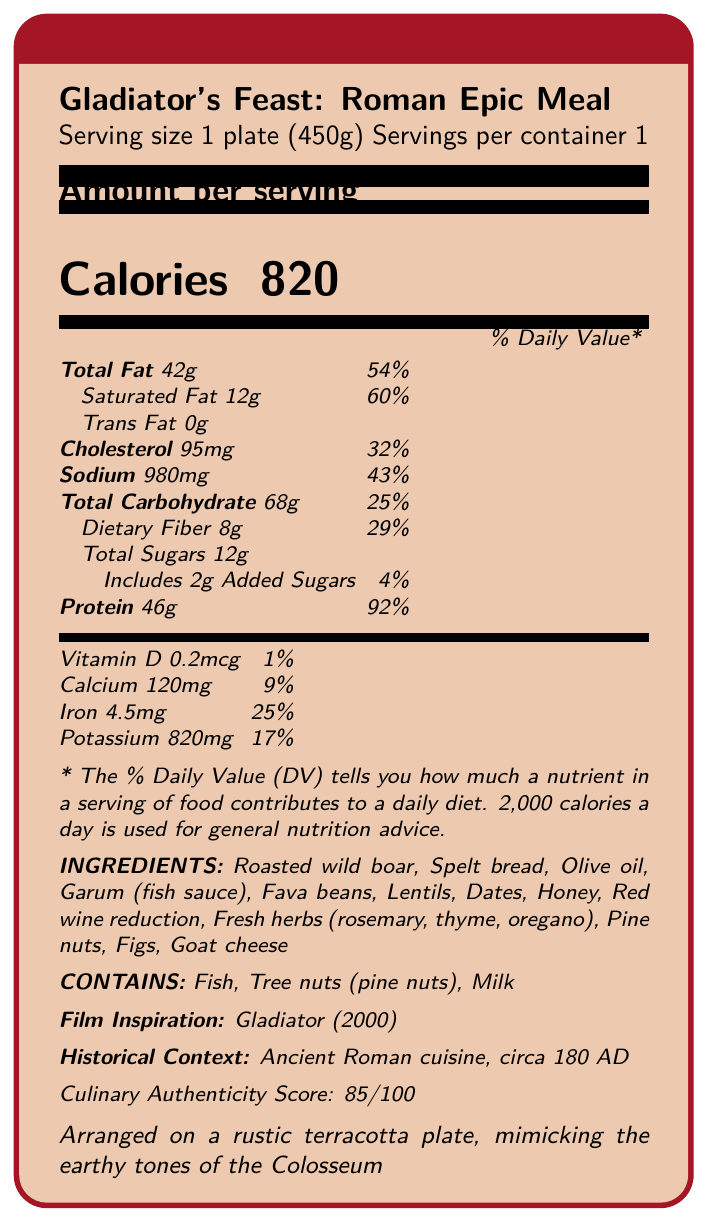what is the serving size of the meal? The document specifies that the serving size is 1 plate, which weighs 450 grams.
Answer: 1 plate (450g) how many calories are in one serving of Gladiator's Feast? The document indicates that each serving of the meal contains 820 calories.
Answer: 820 what is the daily value percentage of iron in the meal? The document shows that the iron content in the meal contributes to 25% of the daily value.
Answer: 25% name three ingredients in the Gladiator's Feast. The ingredients listed include roasted wild boar, spelt bread, and olive oil among others.
Answer: Roasted wild boar, Spelt bread, Olive oil which allergens are present in Gladiator's Feast? The allergens listed are fish, tree nuts (pine nuts), and milk.
Answer: Fish, Tree nuts (pine nuts), Milk the meal is inspired by which film? A. Ben-Hur (1959) B. Gladiator (2000) C. Spartacus (1960) The document indicates that the meal is inspired by the film "Gladiator" (2000).
Answer: B which of the following nutrients has the highest percentage daily value in the meal? I. Total Fat II. Protein III. Dietary Fiber IV. Sodium Protein has the highest percentage daily value at 92%, while Total Fat is at 54%, Dietary Fiber at 29%, and Sodium at 43%.
Answer: II. Protein is the gluten content of the meal specified? The document does not provide information about the gluten content of the meal.
Answer: No summarize the document. The document is a detailed nutrition facts label that includes comprehensive data about the meal's nutritional breakdown, its ingredients, and its connection to the historical epic film "Gladiator" and Ancient Roman cuisine.
Answer: The document provides nutritional information about a film set meal called "Gladiator's Feast: Roman Epic Meal." It mentions serving size, caloric content, various nutrients and their daily value percentages, ingredients, allergens, film inspiration, historical context, and culinary authenticity score. how much sodium does the meal contain? The sodium content of the meal is listed as 980 mg.
Answer: 980 mg what are the nutritional highlights of the Gladiator's Feast? The document lists the nutritional highlights, noting that the meal is high in protein and healthy fats, a good source of complex carbohydrates, and contains antioxidants.
Answer: High in protein from wild boar and legumes, rich in healthy fats from olive oil and pine nuts, good source of complex carbohydrates from spelt bread, contains antioxidants from red wine reduction and fresh herbs what percentage of the daily value for calcium does the meal provide? The meal provides 9% of the daily value for calcium.
Answer: 9% is the meal arranged on a metal plate? The document specifies that the meal is arranged on a rustic terracotta plate, not a metal one.
Answer: No can you determine the exact amount of antioxidants in the meal? The document mentions that the meal contains antioxidants from red wine reduction and fresh herbs but does not specify the exact amount.
Answer: Not enough information 